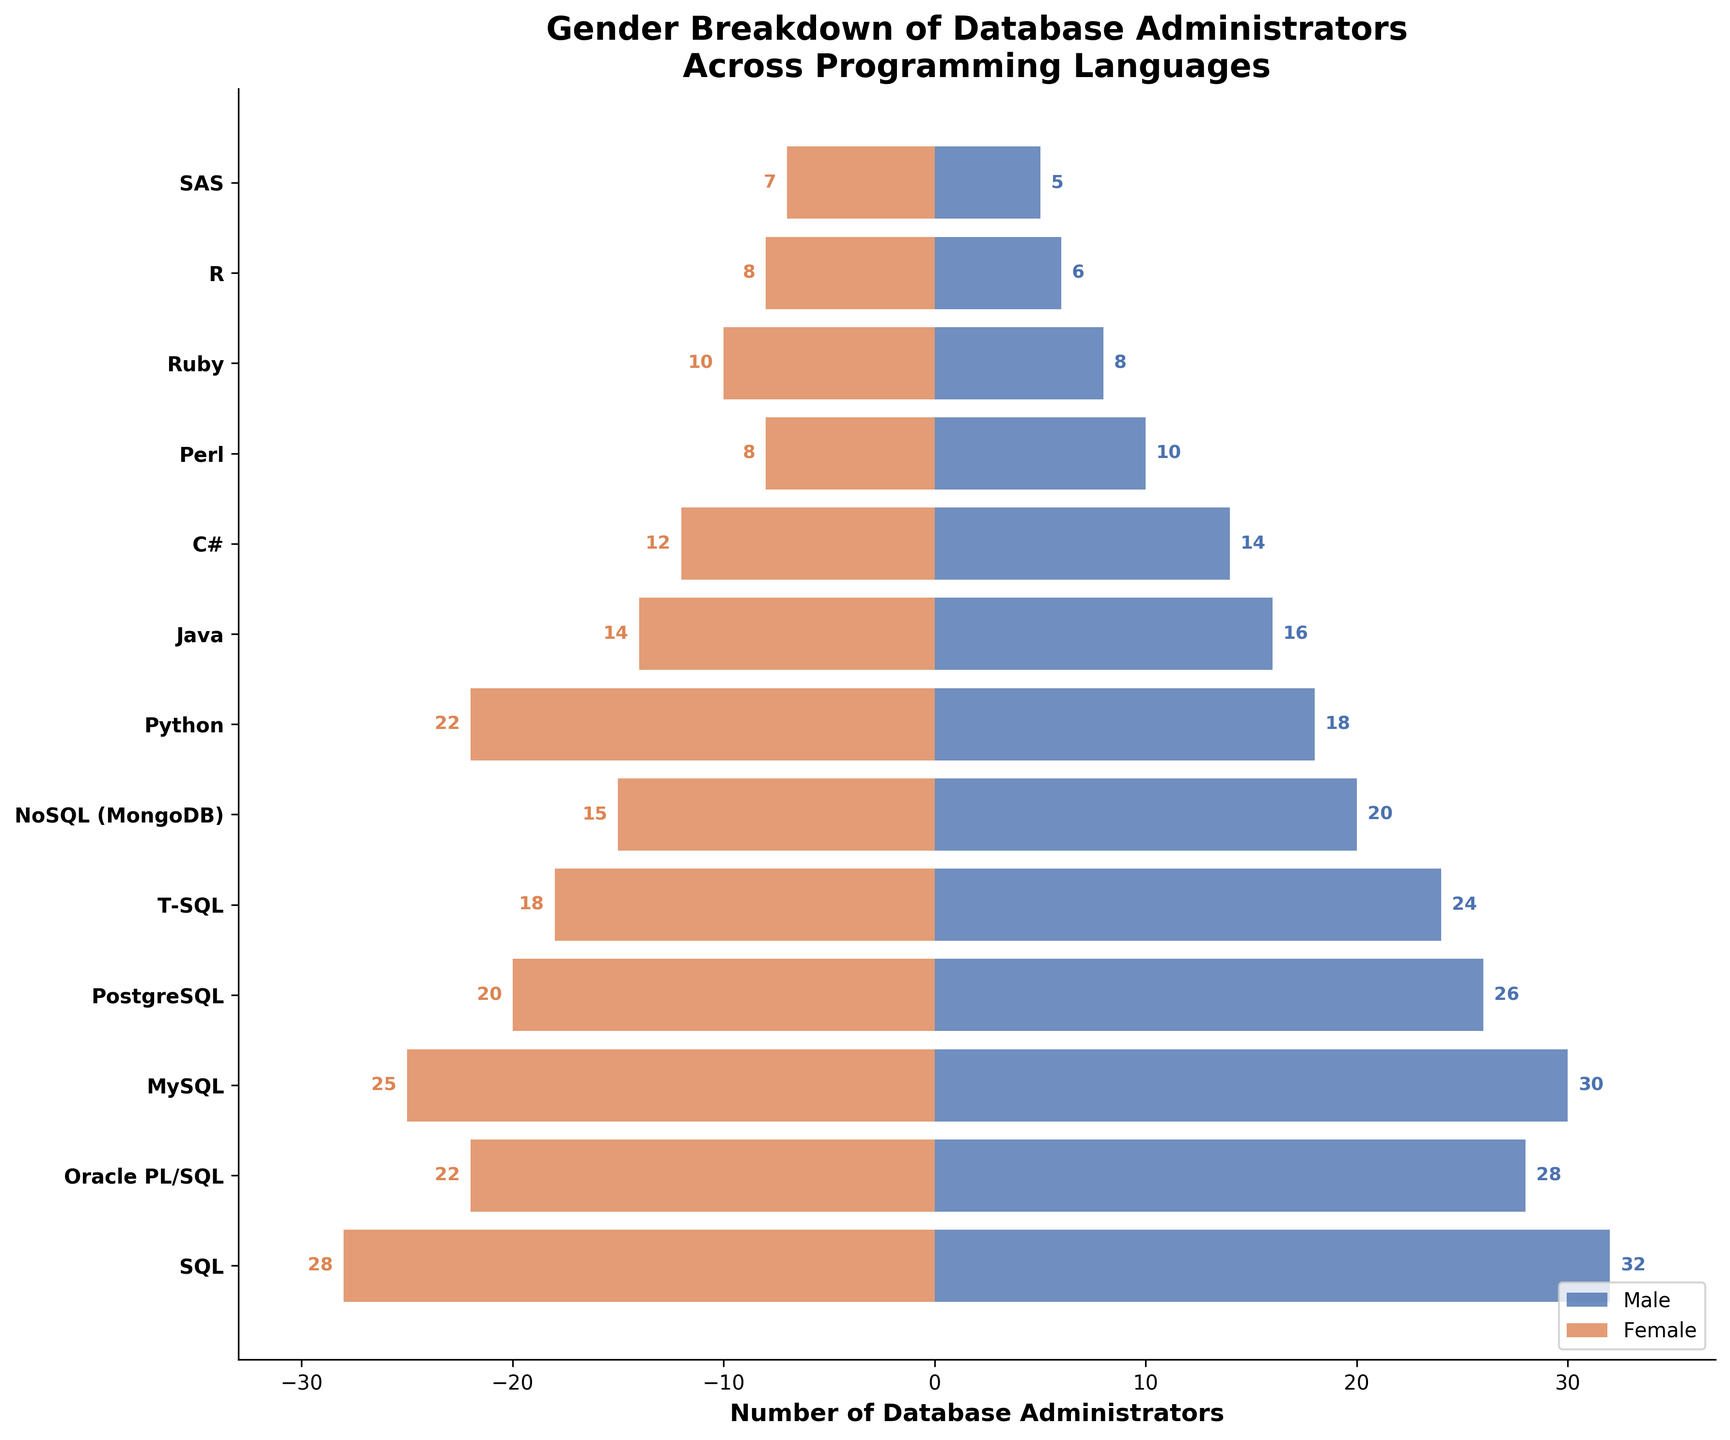What is the title of the figure? The title is typically found at the top of the figure. In this case, it reads "Gender Breakdown of Database Administrators Across Programming Languages"
Answer: Gender Breakdown of Database Administrators Across Programming Languages How many languages have more female database administrators than male? By visually inspecting the lengths of bars, Ruby, R, and SAS have longer bars on the female side compared to the male side.
Answer: 3 What is the total number of female database administrators for SQL-related languages (SQL, Oracle PL/SQL, MySQL, PostgreSQL, T-SQL)? Add the values for female administrators in these languages: 28 (SQL) + 22 (Oracle PL/SQL) + 25 (MySQL) + 20 (PostgreSQL) + 18 (T-SQL). Thus, 28 + 22 + 25 + 20 + 18 = 113
Answer: 113 Which language has the highest number of male database administrators? By comparing the lengths of the blue bars on the male side, SQL has the longest bar.
Answer: SQL What is the difference in the number of male and female database administrators for Python? The number of male administrators is 18 and the number of female administrators is 22; the difference is calculated as 22 - 18 = 4.
Answer: 4 Between PostgreSQL and MySQL, which language has fewer total database administrators? Calculate the total for each: PostgreSQL (26 male + 20 female = 46), MySQL (30 male + 25 female = 55). Comparing these, PostgreSQL is fewer.
Answer: PostgreSQL Which languages have exactly 8 female database administrators? Visual inspection shows that Perl, Ruby, and R each have a bar of length 8 on the female side.
Answer: Perl, Ruby, R In which language is the gender disparity largest (absolute difference between male and female administrators)? Calculate differences: SQL (32-28=4), Oracle PL/SQL (28-22=6), MySQL (30-25=5), etc. The largest disparity is between PostgreSQL (26-20=6).
Answer: Oracle PL/SQL What is the combined total number of database administrators in Oracle PL/SQL and T-SQL? Add the totals for both languages: Oracle PL/SQL (28 male + 22 female = 50), T-SQL (24 male + 18 female = 42); thus, 50 + 42 = 92.
Answer: 92 